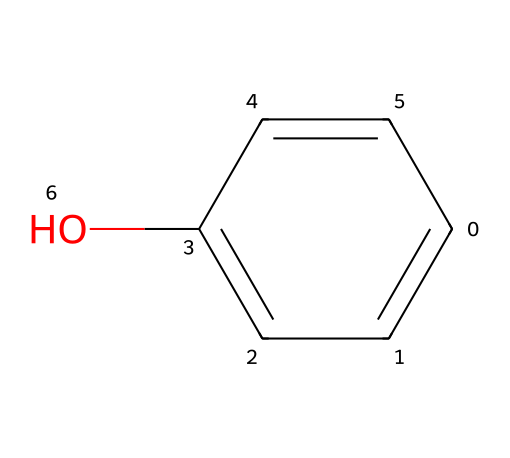What is the molecular formula of phenol? To derive the molecular formula from the SMILES representation, we identify the atoms present. The structure contains six carbon atoms (c), six hydrogen atoms (H), and one oxygen atom (O). Thus, the molecular formula is C6H6O.
Answer: C6H6O How many hydrogen atoms are present in phenol? From the molecular structure analysis, phenol has six carbon atoms and one hydroxyl group (−OH), accounting for five hydrogen atoms bonded to the carbon atoms, plus one from the hydroxyl group, resulting in six hydrogen atoms total.
Answer: 6 What functional group is present in phenol? The OH group (hydroxyl group) attached to the aromatic ring is characteristic of phenols, which indicates its classification as a phenolic compound.
Answer: hydroxyl How many double bonds are in phenol? Analyzing the structure, phenol has alternating single and double bonds in its benzene ring (hexagonal structure), which contains three double bonds in total.
Answer: 3 Is phenol a polar or non-polar compound? Considering the presence of the hydroxyl group, which is polar due to the electronegative oxygen atom, phenol exhibits overall polarity; thus, it can form hydrogen bonds.
Answer: polar What type of compound is phenol classified as? Given its aromatic ring structure and the presence of a hydroxyl group, phenol is classified as an aromatic alcohol.
Answer: aromatic alcohol What is the role of phenol in cleaning products? Phenol acts as a disinfectant due to its ability to kill bacteria and viruses, making it a common active ingredient in many cleaning formulations.
Answer: disinfectant 